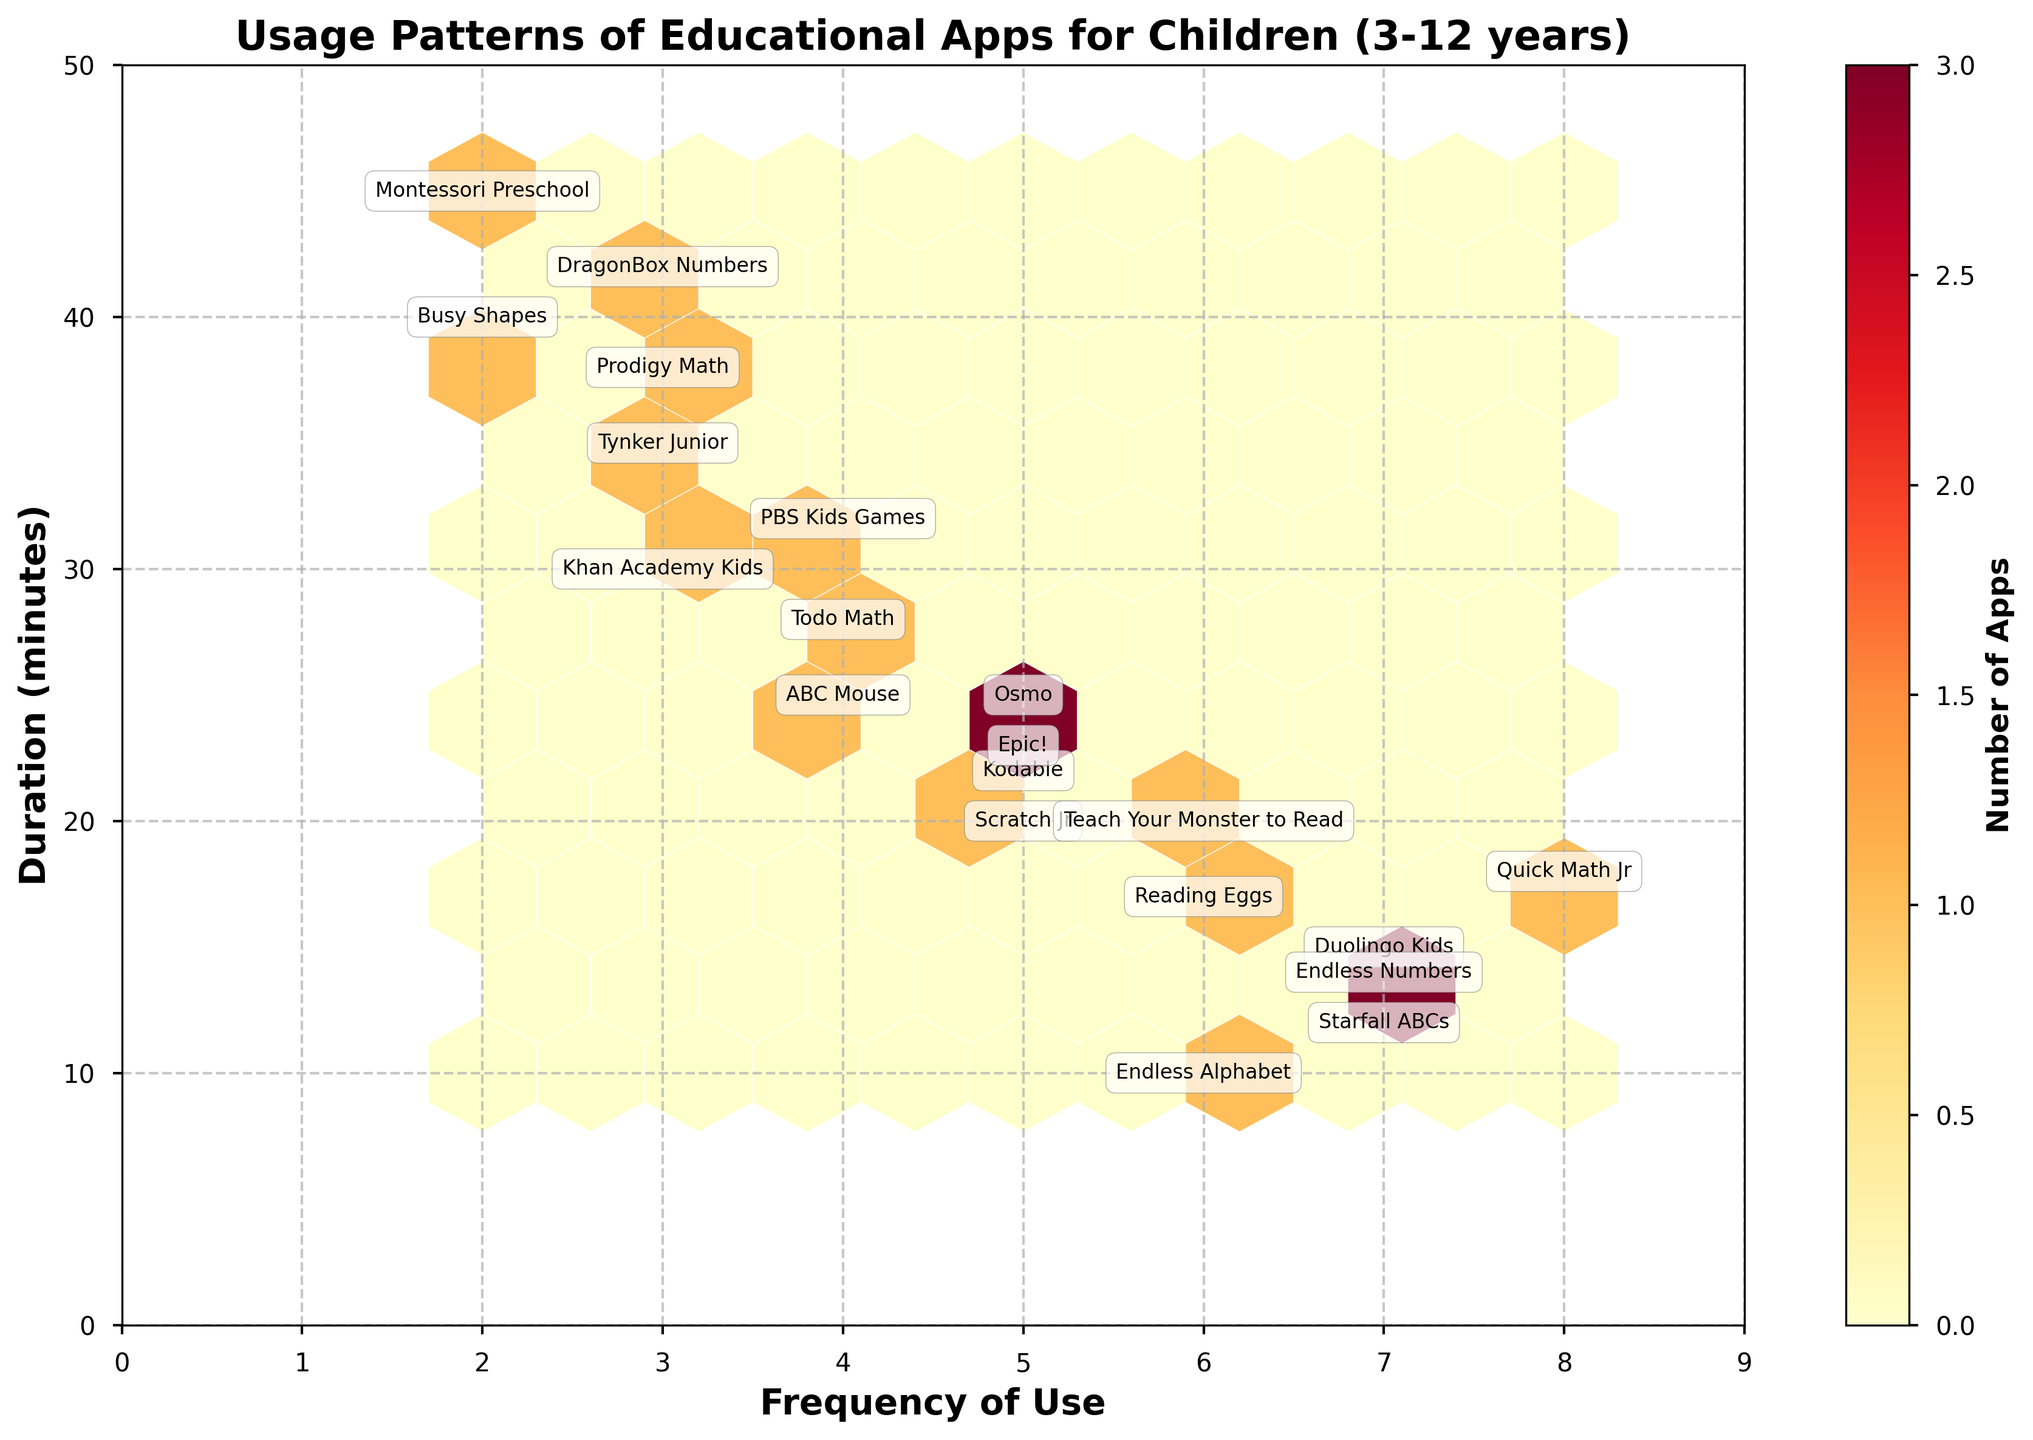What is the title of the hexbin plot? The title of a plot is usually located at the top of the figure and is often in a larger font size for easy identification.
Answer: Usage Patterns of Educational Apps for Children (3-12 years) What are the labels for the x-axis and y-axis? Axis labels are generally placed alongside or below the respective axes to describe what each axis represents.
Answer: Frequency of Use (x-axis), Duration (minutes) (y-axis) How many apps have a frequency of use of 5 times per week? Locate all the hexagonal bins that correspond to an x-axis value of 5, and count the number of distinct apps annotated within them.
Answer: 4 Which app is used most frequently and for the shortest duration? Identify the data point where the frequency value is the highest and the corresponding duration value is the lowest among those data points.
Answer: Quick Math Jr What is the range of durations for apps that are used 3 times a week? Identify the y-axis values annotated with the apps "Khan Academy Kids," "Tynker Junior," "Prodigy Math," and "DragonBox Numbers," and find the range (difference between maximum and minimum values).
Answer: 30 to 42 minutes Which app is used less frequently than "ABC Mouse" and for a longer duration than "ABC Mouse"? Compare the frequency and duration values of other apps against those for "ABC Mouse," which has a frequency of 4 and duration of 25 minutes.
Answer: Busy Shapes What is the mean duration of use for apps with a usage frequency of 7 times per week? Calculate the average duration by summing the durations (15, 12, 14, 18) for the apps used 7 times a week and dividing by the number of those apps.
Answer: 14.75 minutes How many apps fall into the hexagon with the highest frequency of use and longest duration? Find the hexagonal bin at the upper-rightmost corner of the figure that has the maximum frequency count according to the color gradient (darker hexagons represent higher counts).
Answer: 1 Which educational app has the longest duration of use within the plot? Identify the y-axis value that is the highest among all the annotated points and note down the corresponding app.
Answer: Montessori Preschool Are there more apps used between 5-10 times per week or between 1-4 times per week? Count the number of hexagonal bins that fall within the x-axis ranges 5-10 and 1-4, respectively.
Answer: 5-10 times per week 